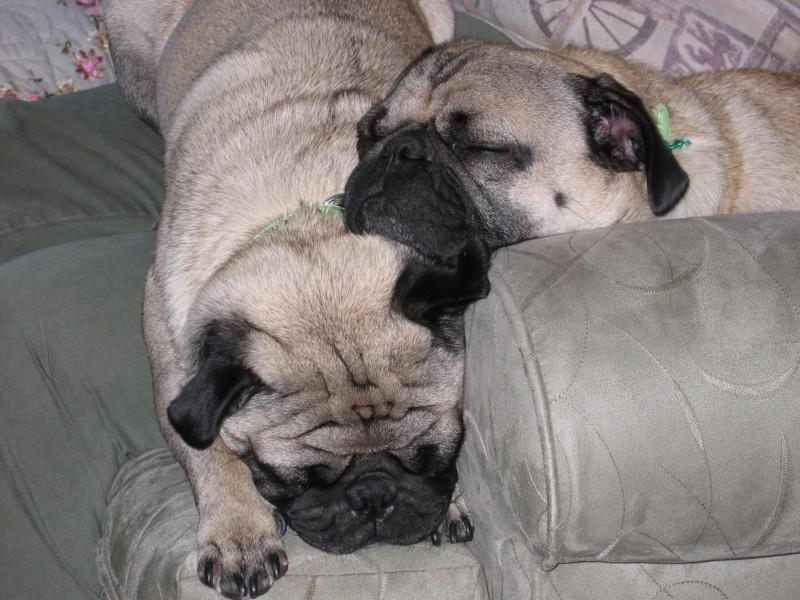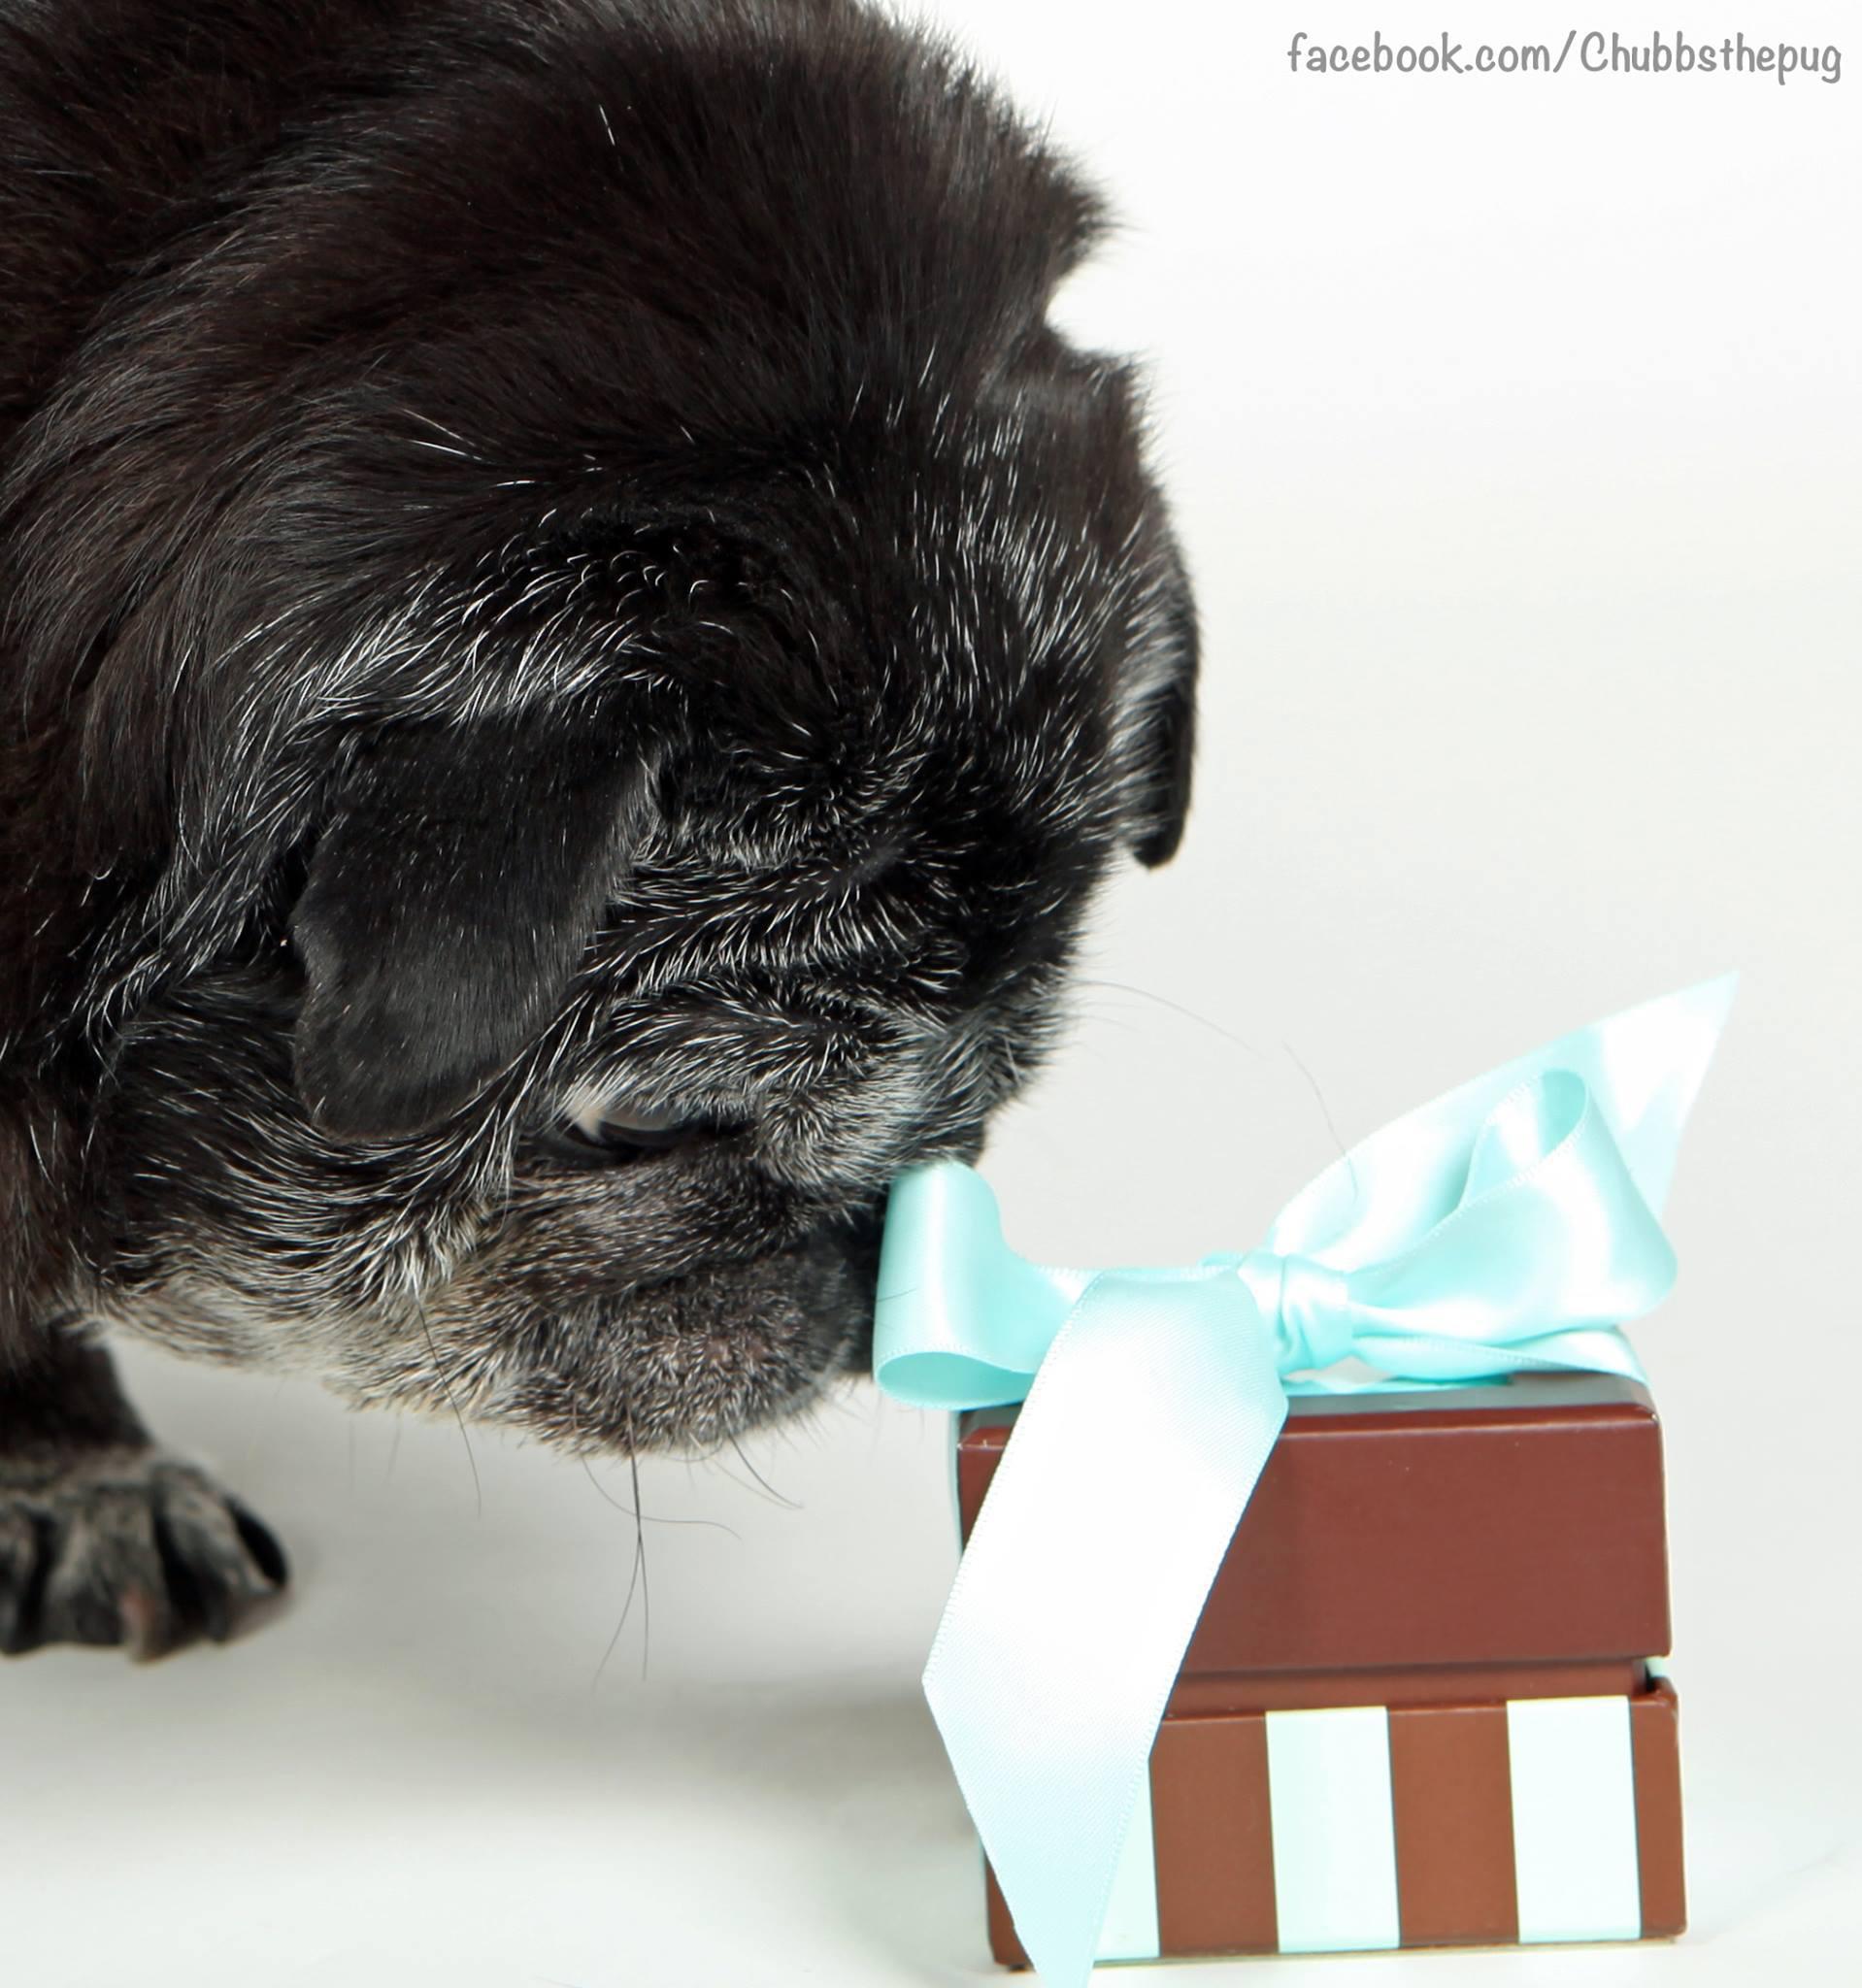The first image is the image on the left, the second image is the image on the right. For the images shown, is this caption "Both images show a single pug and in one it has its tongue sticking out." true? Answer yes or no. No. The first image is the image on the left, the second image is the image on the right. For the images displayed, is the sentence "Each image features one camera-gazing buff-beige pug with a dark muzzle, and one pug has its tongue sticking out." factually correct? Answer yes or no. No. 